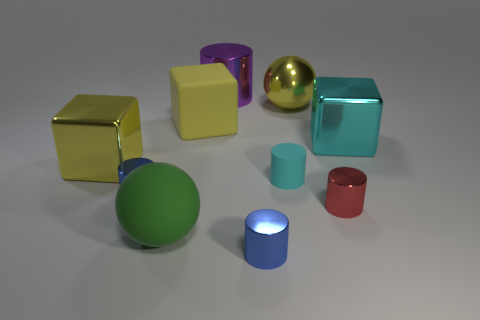Subtract all red cylinders. How many cylinders are left? 4 Subtract all tiny cyan cylinders. How many cylinders are left? 4 Subtract all gray cylinders. Subtract all red balls. How many cylinders are left? 5 Subtract all cubes. How many objects are left? 7 Subtract 0 brown spheres. How many objects are left? 10 Subtract all big green matte things. Subtract all brown objects. How many objects are left? 9 Add 4 green matte spheres. How many green matte spheres are left? 5 Add 3 large objects. How many large objects exist? 9 